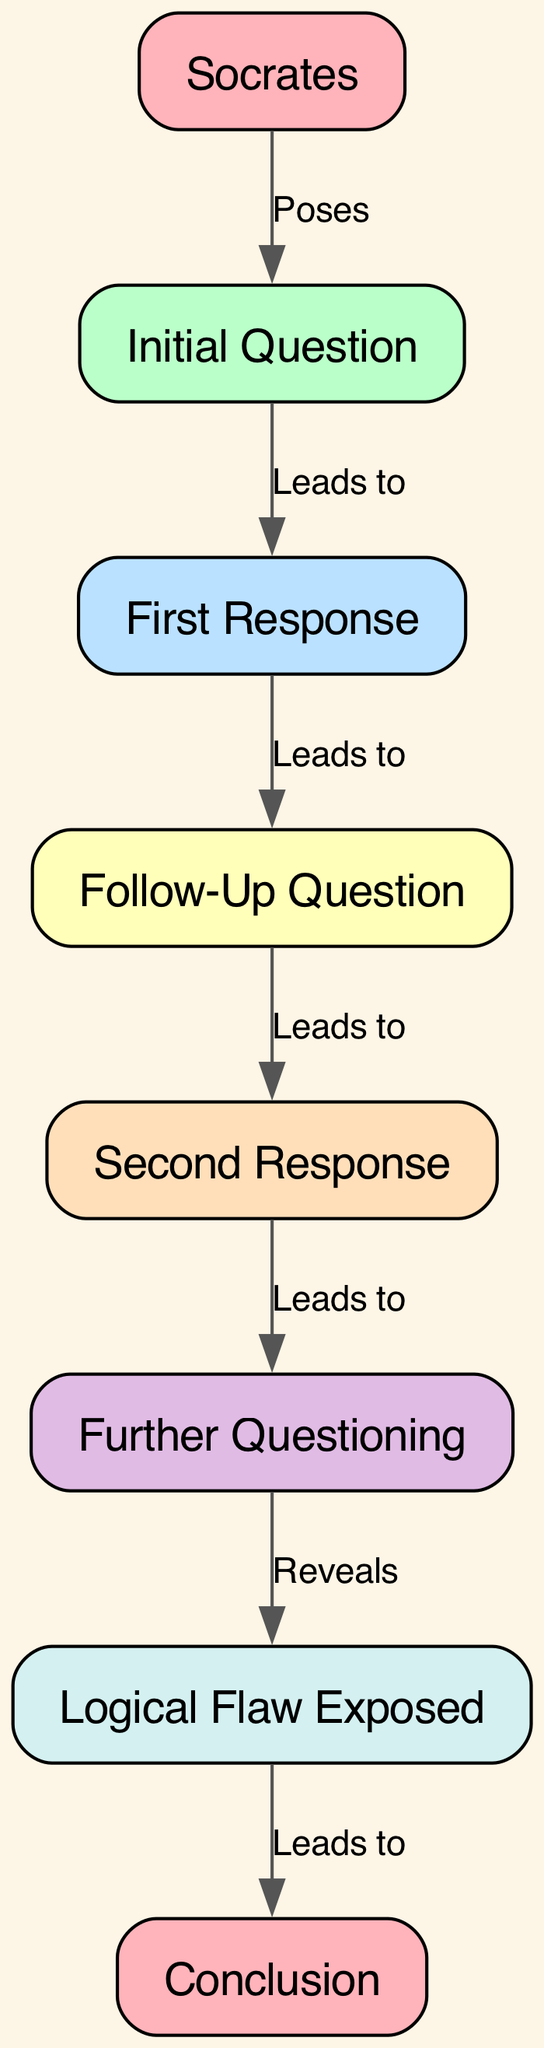What is the first question in the dialogue? The first node in the diagram is labeled "Initial Question," which is directly referenced and does not require any additional context. It is the first step in the flow of the dialogue.
Answer: Initial Question How many nodes are present in the diagram? Count the total number of unique nodes listed in the data: Socrates, Initial Question, First Response, Follow-Up Question, Second Response, Further Questioning, Logical Flaw Exposed, and Conclusion. Adding these gives a total of 8 nodes.
Answer: 8 What edge leads to the Logical Flaw Exposed? Trace the edges in the diagram. The edge leading to "Logical Flaw Exposed" comes from "Follow-Up Question 2," which connects as the final step before reaching this node, indicating progression through the dialogue.
Answer: Follow-Up Question 2 What role does Socrates play in this dialogue structure? The diagram shows that Socrates poses the "Initial Question," which is the starting point of the entire dialogue. Therefore, Socrates' role is to initiate the discussion.
Answer: Poses What does the edge labeled "Reveals" signify in the diagram? The edge labeled "Reveals" indicates that the "Further Questioning" leads to the discovery of a "Logical Flaw Exposed." This connection emphasizes the critical nature of Socratic questioning in uncovering contradictions or gaps in reasoning.
Answer: Reveals Which response follows the first response? The diagram indicates a direct flow from "First Response" to "Follow-Up Question 1," showing that this is the subsequent step in the dialogue following the first response.
Answer: Follow-Up Question 1 What is the conclusion derived from the dialogue? The last node in the diagram is labeled "Conclusion," indicating that this represents the final outcome or understanding reached after analyzing the preceding nodes and their connections throughout the dialogue.
Answer: Conclusion How many edges are there in the diagram? To find the number of edges, count the connections between nodes specified in the data: Socrates to Question, Question to Response 1, Response 1 to Follow-Up Question 1, Follow-Up Question 1 to Response 2, Response 2 to Follow-Up Question 2, Follow-Up Question 2 to Logical Flaw Exposed, and Logical Flaw Exposed to Conclusion. This results in a total of 7 edges.
Answer: 7 